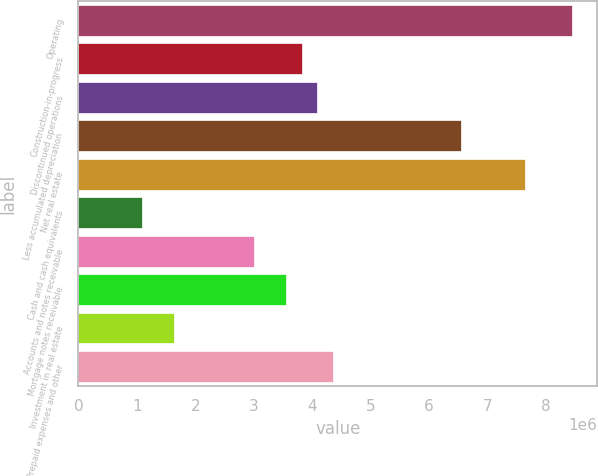<chart> <loc_0><loc_0><loc_500><loc_500><bar_chart><fcel>Operating<fcel>Construction-in-progress<fcel>Discontinued operations<fcel>Less accumulated depreciation<fcel>Net real estate<fcel>Cash and cash equivalents<fcel>Accounts and notes receivable<fcel>Mortgage notes receivable<fcel>Investment in real estate<fcel>Prepaid expenses and other<nl><fcel>8.45407e+06<fcel>3.81827e+06<fcel>4.09096e+06<fcel>6.54521e+06<fcel>7.63599e+06<fcel>1.09132e+06<fcel>3.00018e+06<fcel>3.54557e+06<fcel>1.63671e+06<fcel>4.36365e+06<nl></chart> 